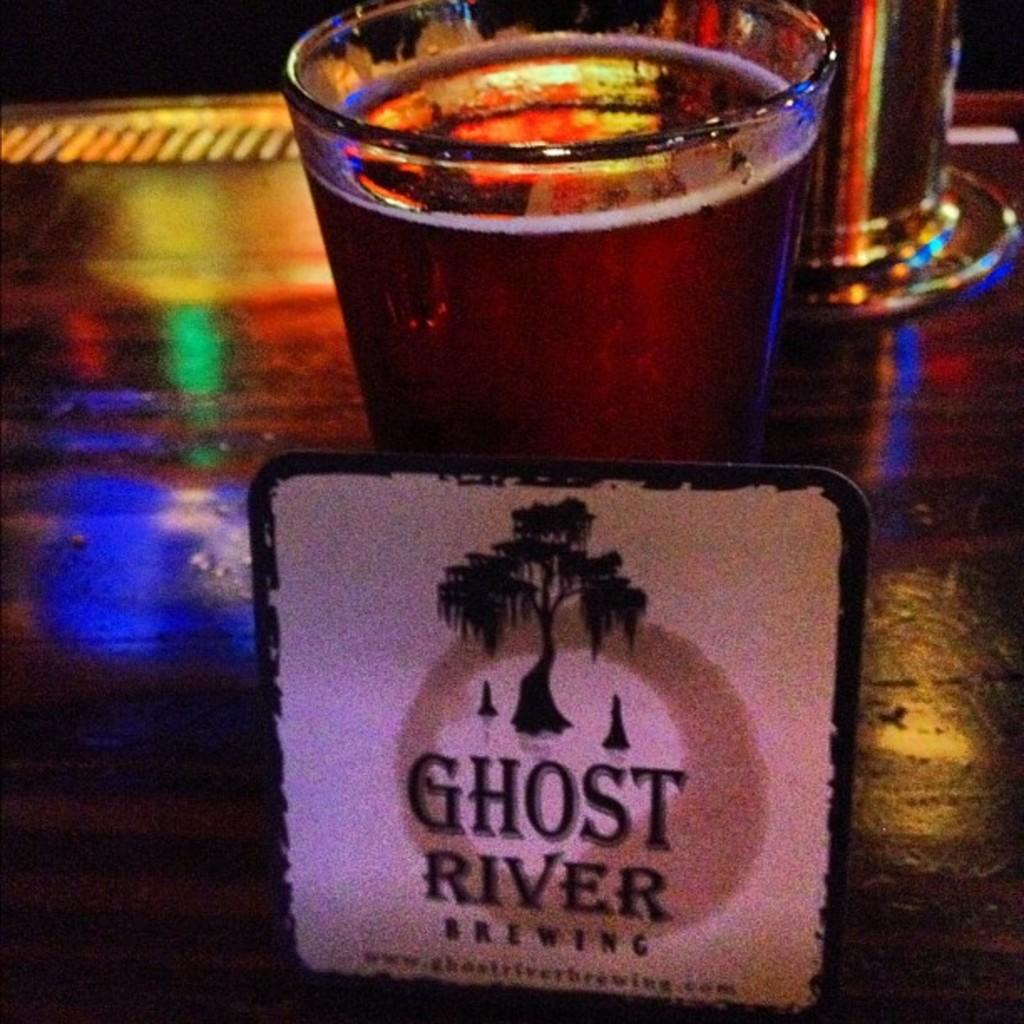<image>
Share a concise interpretation of the image provided. A coaster for a brewing company rests on a glass of beer. 